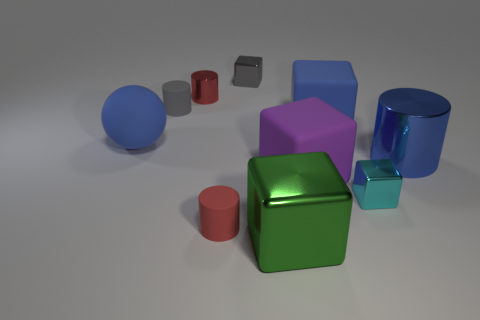How many blue matte things are in front of the big metal thing to the left of the purple block?
Offer a terse response. 0. There is a tiny cyan thing that is the same shape as the big green metallic thing; what is it made of?
Your answer should be very brief. Metal. What color is the ball?
Give a very brief answer. Blue. How many objects are either purple rubber things or large green metal objects?
Keep it short and to the point. 2. There is a gray object that is to the right of the tiny red cylinder that is behind the large blue matte sphere; what is its shape?
Ensure brevity in your answer.  Cube. What number of other things are made of the same material as the gray cylinder?
Your response must be concise. 4. Is the big green cube made of the same material as the block to the left of the large green metal thing?
Provide a short and direct response. Yes. What number of objects are either small cylinders that are in front of the gray cylinder or blue rubber objects that are on the right side of the tiny gray cylinder?
Offer a terse response. 2. What number of other objects are the same color as the small metal cylinder?
Offer a terse response. 1. Is the number of gray shiny cubes in front of the big matte sphere greater than the number of purple objects in front of the tiny red matte thing?
Offer a very short reply. No. 